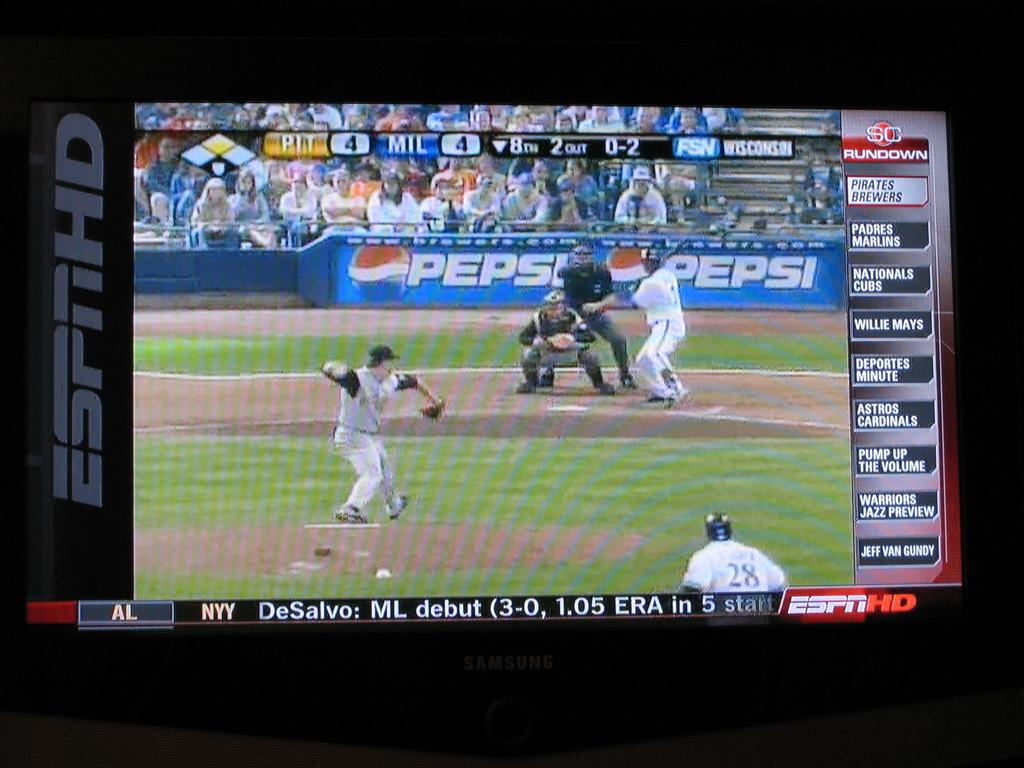Provide a one-sentence caption for the provided image. a pepsi logo that is behind the batter. 